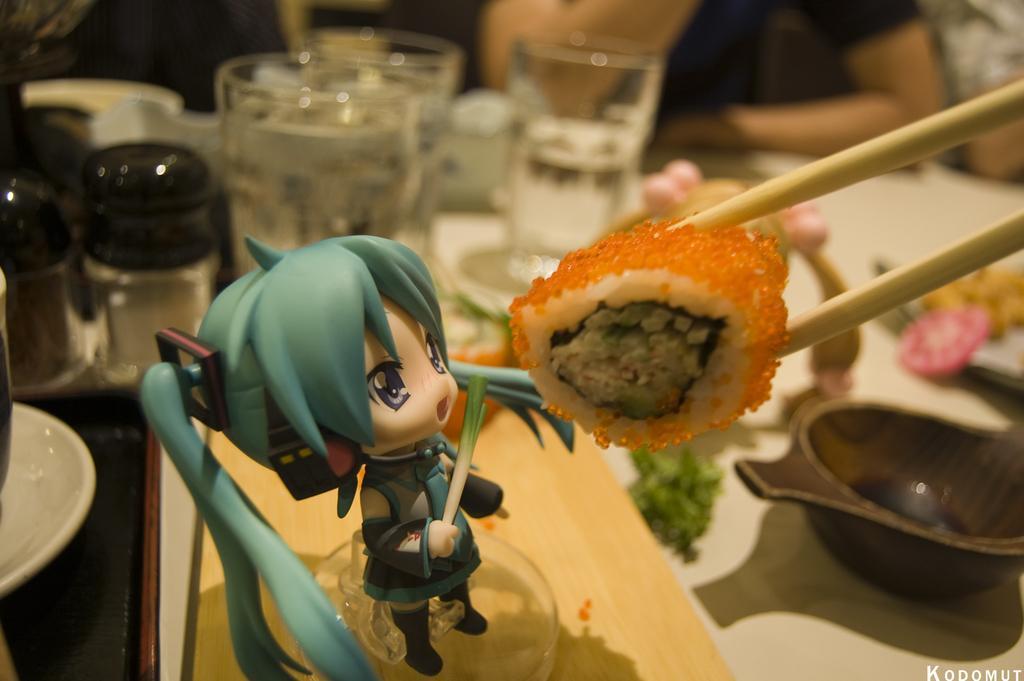In one or two sentences, can you explain what this image depicts? In the image we can see there is a toy of a girl which is standing and in front of her there is a chopsticks and in between there is a sushi and at the back on the table there are water glass, paper and salt bottles, bowl, broccoli and other food items. 